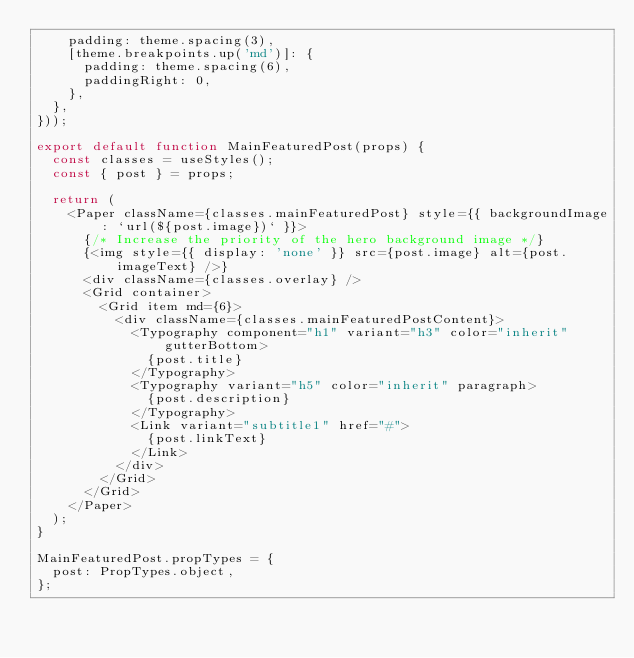<code> <loc_0><loc_0><loc_500><loc_500><_JavaScript_>    padding: theme.spacing(3),
    [theme.breakpoints.up('md')]: {
      padding: theme.spacing(6),
      paddingRight: 0,
    },
  },
}));

export default function MainFeaturedPost(props) {
  const classes = useStyles();
  const { post } = props;

  return (
    <Paper className={classes.mainFeaturedPost} style={{ backgroundImage: `url(${post.image})` }}>
      {/* Increase the priority of the hero background image */}
      {<img style={{ display: 'none' }} src={post.image} alt={post.imageText} />}
      <div className={classes.overlay} />
      <Grid container>
        <Grid item md={6}>
          <div className={classes.mainFeaturedPostContent}>
            <Typography component="h1" variant="h3" color="inherit" gutterBottom>
              {post.title}
            </Typography>
            <Typography variant="h5" color="inherit" paragraph>
              {post.description}
            </Typography>
            <Link variant="subtitle1" href="#">
              {post.linkText}
            </Link>
          </div>
        </Grid>
      </Grid>
    </Paper>
  );
}

MainFeaturedPost.propTypes = {
  post: PropTypes.object,
};
</code> 